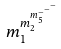Convert formula to latex. <formula><loc_0><loc_0><loc_500><loc_500>m _ { 1 } ^ { m _ { 2 } ^ { m _ { 5 } ^ { - ^ { - ^ { - } } } } }</formula> 